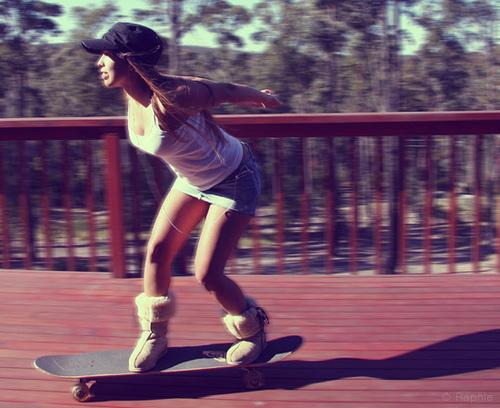Is this skateboarder a man?
Concise answer only. No. Is the skateboarder moving to the left or to the right?
Write a very short answer. Left. Is the image blurry?
Quick response, please. Yes. 